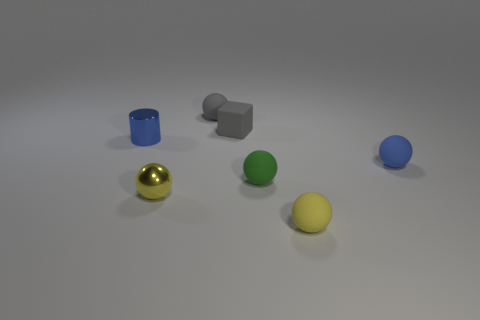Subtract all blue rubber spheres. How many spheres are left? 4 Add 3 tiny gray rubber blocks. How many objects exist? 10 Subtract all spheres. How many objects are left? 2 Subtract all gray spheres. How many spheres are left? 4 Subtract 1 blocks. How many blocks are left? 0 Subtract all small brown things. Subtract all green things. How many objects are left? 6 Add 3 blue cylinders. How many blue cylinders are left? 4 Add 2 small cubes. How many small cubes exist? 3 Subtract 0 red cylinders. How many objects are left? 7 Subtract all brown cubes. Subtract all purple cylinders. How many cubes are left? 1 